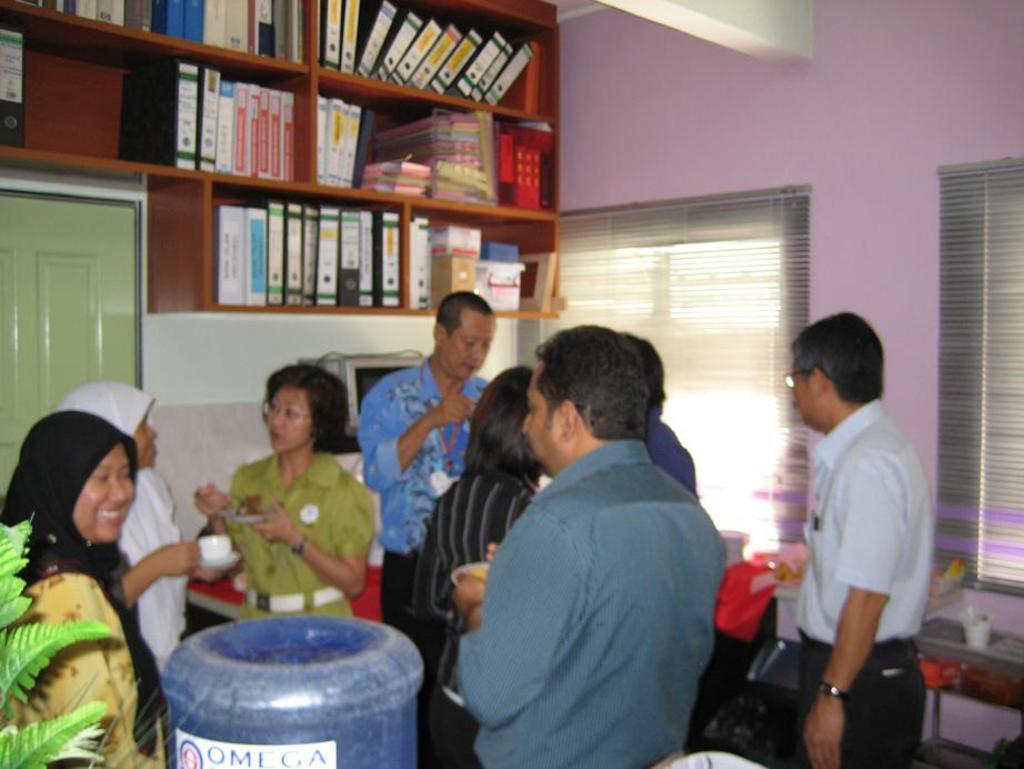How would you summarize this image in a sentence or two? In this image there are group of persons standing, they are holding an object, there are objects truncated towards the bottom of the image, there is an object truncated towards the right of the image, there is wall truncated towards the right of the image, there is wall truncated towards the top of the image, there are shelves truncated towards the top of the image, there are books in the shelf, there is a door truncated towards the left of the image, there is an object behind the person, there is wall behind the person, there is a window truncated towards the right of the image. 